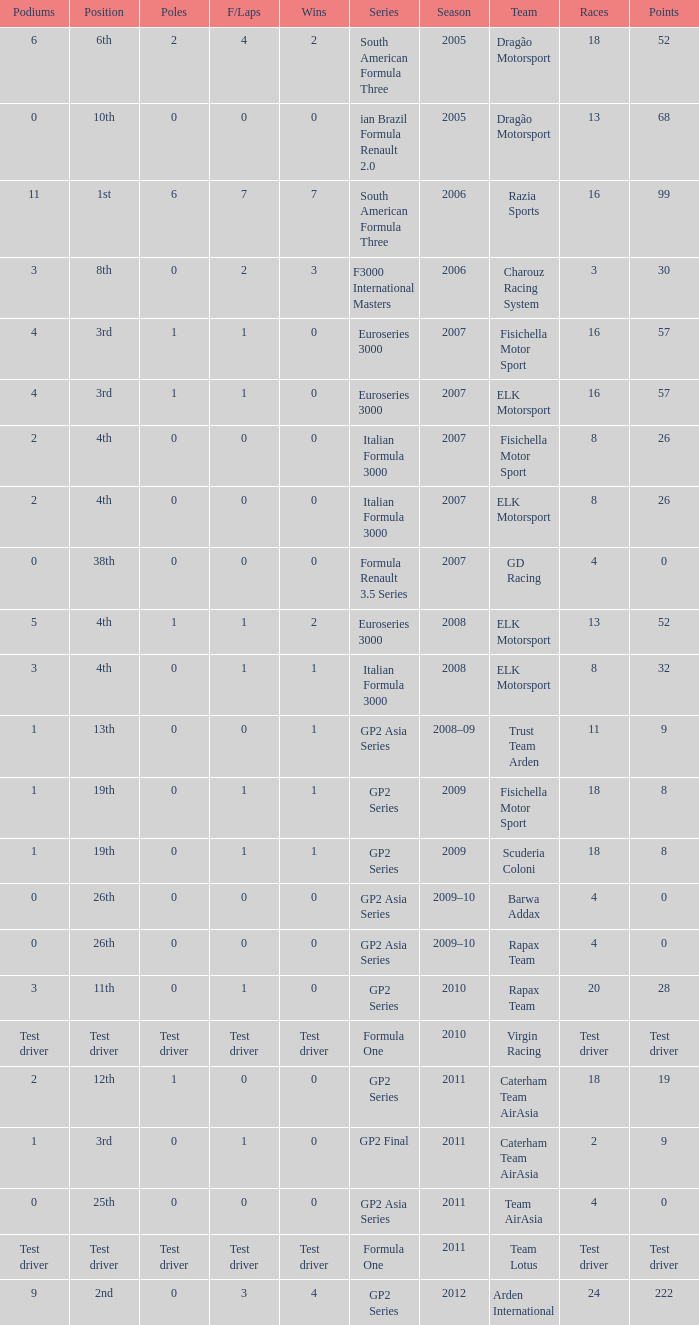What were the points in the year when his Podiums were 5? 52.0. 